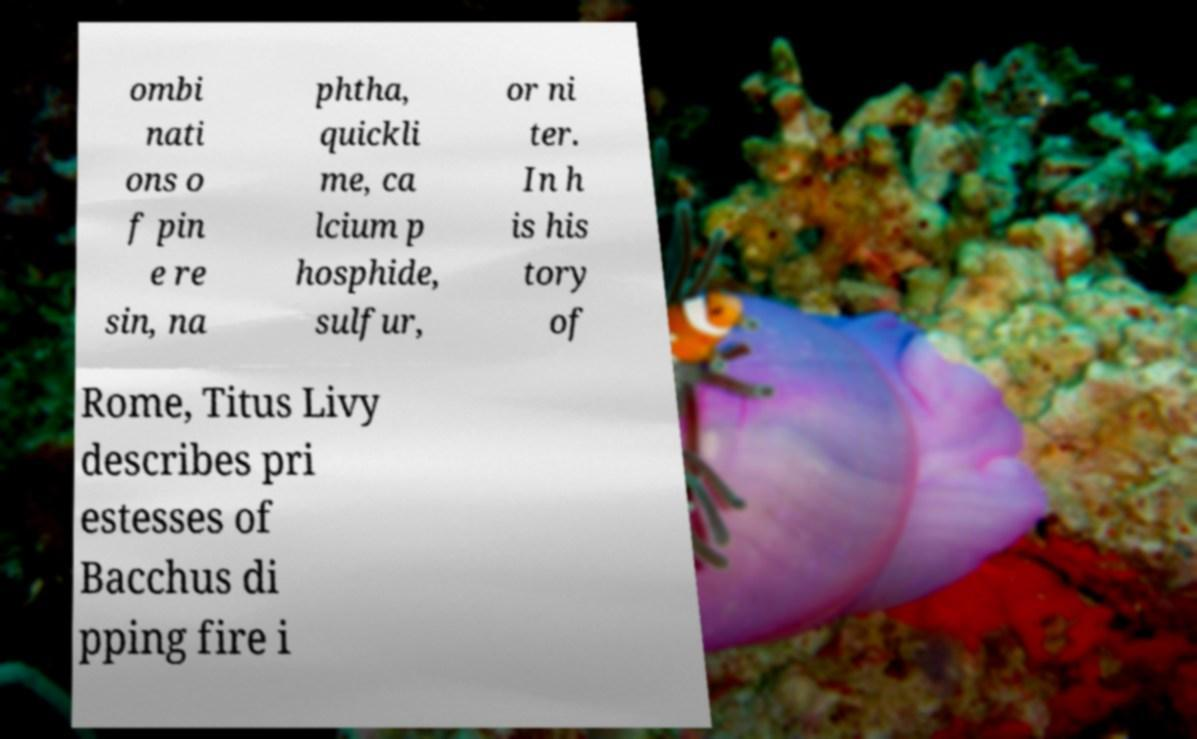Please read and relay the text visible in this image. What does it say? ombi nati ons o f pin e re sin, na phtha, quickli me, ca lcium p hosphide, sulfur, or ni ter. In h is his tory of Rome, Titus Livy describes pri estesses of Bacchus di pping fire i 